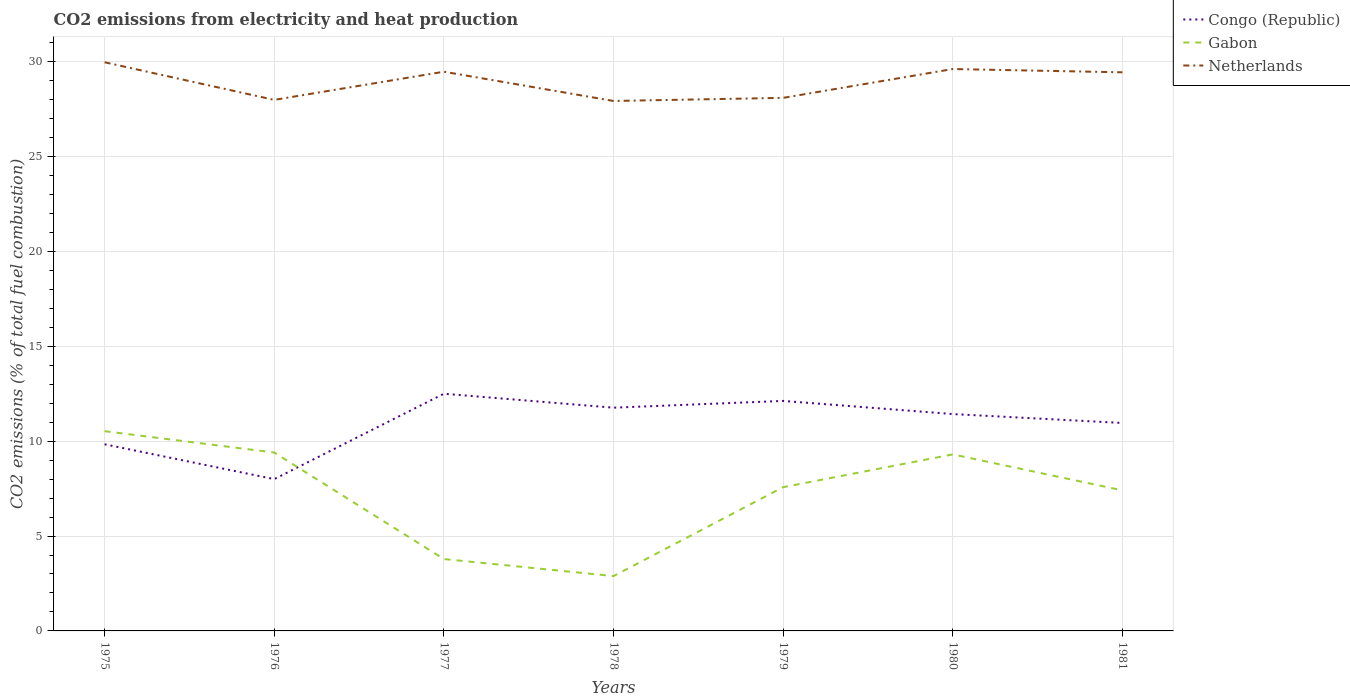Does the line corresponding to Gabon intersect with the line corresponding to Netherlands?
Your answer should be compact. No. Across all years, what is the maximum amount of CO2 emitted in Gabon?
Provide a succinct answer. 2.89. In which year was the amount of CO2 emitted in Gabon maximum?
Give a very brief answer. 1978. What is the total amount of CO2 emitted in Congo (Republic) in the graph?
Offer a very short reply. 0.47. What is the difference between the highest and the lowest amount of CO2 emitted in Gabon?
Your answer should be very brief. 5. How many lines are there?
Offer a very short reply. 3. Does the graph contain grids?
Make the answer very short. Yes. Where does the legend appear in the graph?
Make the answer very short. Top right. How are the legend labels stacked?
Make the answer very short. Vertical. What is the title of the graph?
Ensure brevity in your answer.  CO2 emissions from electricity and heat production. What is the label or title of the X-axis?
Give a very brief answer. Years. What is the label or title of the Y-axis?
Make the answer very short. CO2 emissions (% of total fuel combustion). What is the CO2 emissions (% of total fuel combustion) of Congo (Republic) in 1975?
Provide a succinct answer. 9.84. What is the CO2 emissions (% of total fuel combustion) in Gabon in 1975?
Offer a very short reply. 10.53. What is the CO2 emissions (% of total fuel combustion) in Netherlands in 1975?
Offer a terse response. 29.97. What is the CO2 emissions (% of total fuel combustion) of Gabon in 1976?
Offer a terse response. 9.4. What is the CO2 emissions (% of total fuel combustion) in Netherlands in 1976?
Provide a short and direct response. 27.99. What is the CO2 emissions (% of total fuel combustion) in Congo (Republic) in 1977?
Your response must be concise. 12.5. What is the CO2 emissions (% of total fuel combustion) of Gabon in 1977?
Keep it short and to the point. 3.79. What is the CO2 emissions (% of total fuel combustion) in Netherlands in 1977?
Your response must be concise. 29.47. What is the CO2 emissions (% of total fuel combustion) in Congo (Republic) in 1978?
Make the answer very short. 11.76. What is the CO2 emissions (% of total fuel combustion) in Gabon in 1978?
Ensure brevity in your answer.  2.89. What is the CO2 emissions (% of total fuel combustion) of Netherlands in 1978?
Your answer should be compact. 27.93. What is the CO2 emissions (% of total fuel combustion) in Congo (Republic) in 1979?
Make the answer very short. 12.12. What is the CO2 emissions (% of total fuel combustion) of Gabon in 1979?
Give a very brief answer. 7.58. What is the CO2 emissions (% of total fuel combustion) in Netherlands in 1979?
Your response must be concise. 28.09. What is the CO2 emissions (% of total fuel combustion) of Congo (Republic) in 1980?
Provide a succinct answer. 11.43. What is the CO2 emissions (% of total fuel combustion) of Gabon in 1980?
Offer a very short reply. 9.3. What is the CO2 emissions (% of total fuel combustion) of Netherlands in 1980?
Your answer should be compact. 29.61. What is the CO2 emissions (% of total fuel combustion) of Congo (Republic) in 1981?
Offer a very short reply. 10.96. What is the CO2 emissions (% of total fuel combustion) in Gabon in 1981?
Provide a short and direct response. 7.41. What is the CO2 emissions (% of total fuel combustion) of Netherlands in 1981?
Offer a very short reply. 29.44. Across all years, what is the maximum CO2 emissions (% of total fuel combustion) of Gabon?
Give a very brief answer. 10.53. Across all years, what is the maximum CO2 emissions (% of total fuel combustion) of Netherlands?
Keep it short and to the point. 29.97. Across all years, what is the minimum CO2 emissions (% of total fuel combustion) in Congo (Republic)?
Your answer should be very brief. 8. Across all years, what is the minimum CO2 emissions (% of total fuel combustion) of Gabon?
Offer a very short reply. 2.89. Across all years, what is the minimum CO2 emissions (% of total fuel combustion) of Netherlands?
Provide a short and direct response. 27.93. What is the total CO2 emissions (% of total fuel combustion) in Congo (Republic) in the graph?
Provide a succinct answer. 76.61. What is the total CO2 emissions (% of total fuel combustion) of Gabon in the graph?
Ensure brevity in your answer.  50.89. What is the total CO2 emissions (% of total fuel combustion) in Netherlands in the graph?
Your answer should be very brief. 202.5. What is the difference between the CO2 emissions (% of total fuel combustion) in Congo (Republic) in 1975 and that in 1976?
Your answer should be compact. 1.84. What is the difference between the CO2 emissions (% of total fuel combustion) of Gabon in 1975 and that in 1976?
Keep it short and to the point. 1.12. What is the difference between the CO2 emissions (% of total fuel combustion) in Netherlands in 1975 and that in 1976?
Offer a very short reply. 1.98. What is the difference between the CO2 emissions (% of total fuel combustion) of Congo (Republic) in 1975 and that in 1977?
Your answer should be compact. -2.66. What is the difference between the CO2 emissions (% of total fuel combustion) in Gabon in 1975 and that in 1977?
Make the answer very short. 6.74. What is the difference between the CO2 emissions (% of total fuel combustion) of Netherlands in 1975 and that in 1977?
Provide a short and direct response. 0.5. What is the difference between the CO2 emissions (% of total fuel combustion) in Congo (Republic) in 1975 and that in 1978?
Ensure brevity in your answer.  -1.93. What is the difference between the CO2 emissions (% of total fuel combustion) of Gabon in 1975 and that in 1978?
Make the answer very short. 7.64. What is the difference between the CO2 emissions (% of total fuel combustion) in Netherlands in 1975 and that in 1978?
Make the answer very short. 2.04. What is the difference between the CO2 emissions (% of total fuel combustion) in Congo (Republic) in 1975 and that in 1979?
Offer a terse response. -2.29. What is the difference between the CO2 emissions (% of total fuel combustion) in Gabon in 1975 and that in 1979?
Give a very brief answer. 2.95. What is the difference between the CO2 emissions (% of total fuel combustion) of Netherlands in 1975 and that in 1979?
Your answer should be compact. 1.88. What is the difference between the CO2 emissions (% of total fuel combustion) of Congo (Republic) in 1975 and that in 1980?
Offer a terse response. -1.59. What is the difference between the CO2 emissions (% of total fuel combustion) in Gabon in 1975 and that in 1980?
Ensure brevity in your answer.  1.22. What is the difference between the CO2 emissions (% of total fuel combustion) of Netherlands in 1975 and that in 1980?
Offer a very short reply. 0.36. What is the difference between the CO2 emissions (% of total fuel combustion) in Congo (Republic) in 1975 and that in 1981?
Make the answer very short. -1.12. What is the difference between the CO2 emissions (% of total fuel combustion) in Gabon in 1975 and that in 1981?
Your answer should be very brief. 3.12. What is the difference between the CO2 emissions (% of total fuel combustion) in Netherlands in 1975 and that in 1981?
Give a very brief answer. 0.53. What is the difference between the CO2 emissions (% of total fuel combustion) in Congo (Republic) in 1976 and that in 1977?
Provide a short and direct response. -4.5. What is the difference between the CO2 emissions (% of total fuel combustion) in Gabon in 1976 and that in 1977?
Offer a terse response. 5.61. What is the difference between the CO2 emissions (% of total fuel combustion) of Netherlands in 1976 and that in 1977?
Offer a very short reply. -1.48. What is the difference between the CO2 emissions (% of total fuel combustion) of Congo (Republic) in 1976 and that in 1978?
Keep it short and to the point. -3.76. What is the difference between the CO2 emissions (% of total fuel combustion) in Gabon in 1976 and that in 1978?
Your response must be concise. 6.51. What is the difference between the CO2 emissions (% of total fuel combustion) of Netherlands in 1976 and that in 1978?
Make the answer very short. 0.06. What is the difference between the CO2 emissions (% of total fuel combustion) of Congo (Republic) in 1976 and that in 1979?
Provide a short and direct response. -4.12. What is the difference between the CO2 emissions (% of total fuel combustion) of Gabon in 1976 and that in 1979?
Keep it short and to the point. 1.83. What is the difference between the CO2 emissions (% of total fuel combustion) of Netherlands in 1976 and that in 1979?
Your answer should be very brief. -0.11. What is the difference between the CO2 emissions (% of total fuel combustion) of Congo (Republic) in 1976 and that in 1980?
Offer a very short reply. -3.43. What is the difference between the CO2 emissions (% of total fuel combustion) of Gabon in 1976 and that in 1980?
Your answer should be very brief. 0.1. What is the difference between the CO2 emissions (% of total fuel combustion) in Netherlands in 1976 and that in 1980?
Your answer should be very brief. -1.63. What is the difference between the CO2 emissions (% of total fuel combustion) in Congo (Republic) in 1976 and that in 1981?
Give a very brief answer. -2.96. What is the difference between the CO2 emissions (% of total fuel combustion) of Gabon in 1976 and that in 1981?
Offer a very short reply. 1.99. What is the difference between the CO2 emissions (% of total fuel combustion) in Netherlands in 1976 and that in 1981?
Provide a short and direct response. -1.45. What is the difference between the CO2 emissions (% of total fuel combustion) of Congo (Republic) in 1977 and that in 1978?
Your answer should be compact. 0.74. What is the difference between the CO2 emissions (% of total fuel combustion) of Gabon in 1977 and that in 1978?
Offer a very short reply. 0.9. What is the difference between the CO2 emissions (% of total fuel combustion) of Netherlands in 1977 and that in 1978?
Your answer should be compact. 1.54. What is the difference between the CO2 emissions (% of total fuel combustion) of Congo (Republic) in 1977 and that in 1979?
Keep it short and to the point. 0.38. What is the difference between the CO2 emissions (% of total fuel combustion) of Gabon in 1977 and that in 1979?
Provide a short and direct response. -3.79. What is the difference between the CO2 emissions (% of total fuel combustion) of Netherlands in 1977 and that in 1979?
Your answer should be compact. 1.38. What is the difference between the CO2 emissions (% of total fuel combustion) of Congo (Republic) in 1977 and that in 1980?
Your answer should be compact. 1.07. What is the difference between the CO2 emissions (% of total fuel combustion) of Gabon in 1977 and that in 1980?
Your answer should be very brief. -5.51. What is the difference between the CO2 emissions (% of total fuel combustion) of Netherlands in 1977 and that in 1980?
Ensure brevity in your answer.  -0.14. What is the difference between the CO2 emissions (% of total fuel combustion) of Congo (Republic) in 1977 and that in 1981?
Offer a very short reply. 1.54. What is the difference between the CO2 emissions (% of total fuel combustion) in Gabon in 1977 and that in 1981?
Provide a succinct answer. -3.62. What is the difference between the CO2 emissions (% of total fuel combustion) of Netherlands in 1977 and that in 1981?
Offer a terse response. 0.03. What is the difference between the CO2 emissions (% of total fuel combustion) of Congo (Republic) in 1978 and that in 1979?
Offer a terse response. -0.36. What is the difference between the CO2 emissions (% of total fuel combustion) of Gabon in 1978 and that in 1979?
Your answer should be very brief. -4.69. What is the difference between the CO2 emissions (% of total fuel combustion) of Netherlands in 1978 and that in 1979?
Keep it short and to the point. -0.16. What is the difference between the CO2 emissions (% of total fuel combustion) of Congo (Republic) in 1978 and that in 1980?
Offer a very short reply. 0.34. What is the difference between the CO2 emissions (% of total fuel combustion) of Gabon in 1978 and that in 1980?
Keep it short and to the point. -6.41. What is the difference between the CO2 emissions (% of total fuel combustion) in Netherlands in 1978 and that in 1980?
Your answer should be compact. -1.68. What is the difference between the CO2 emissions (% of total fuel combustion) of Congo (Republic) in 1978 and that in 1981?
Your response must be concise. 0.81. What is the difference between the CO2 emissions (% of total fuel combustion) of Gabon in 1978 and that in 1981?
Your response must be concise. -4.52. What is the difference between the CO2 emissions (% of total fuel combustion) in Netherlands in 1978 and that in 1981?
Provide a succinct answer. -1.51. What is the difference between the CO2 emissions (% of total fuel combustion) of Congo (Republic) in 1979 and that in 1980?
Make the answer very short. 0.69. What is the difference between the CO2 emissions (% of total fuel combustion) of Gabon in 1979 and that in 1980?
Keep it short and to the point. -1.73. What is the difference between the CO2 emissions (% of total fuel combustion) in Netherlands in 1979 and that in 1980?
Your response must be concise. -1.52. What is the difference between the CO2 emissions (% of total fuel combustion) of Congo (Republic) in 1979 and that in 1981?
Ensure brevity in your answer.  1.16. What is the difference between the CO2 emissions (% of total fuel combustion) of Gabon in 1979 and that in 1981?
Make the answer very short. 0.17. What is the difference between the CO2 emissions (% of total fuel combustion) of Netherlands in 1979 and that in 1981?
Your answer should be very brief. -1.35. What is the difference between the CO2 emissions (% of total fuel combustion) in Congo (Republic) in 1980 and that in 1981?
Your answer should be very brief. 0.47. What is the difference between the CO2 emissions (% of total fuel combustion) of Gabon in 1980 and that in 1981?
Keep it short and to the point. 1.89. What is the difference between the CO2 emissions (% of total fuel combustion) of Netherlands in 1980 and that in 1981?
Ensure brevity in your answer.  0.17. What is the difference between the CO2 emissions (% of total fuel combustion) of Congo (Republic) in 1975 and the CO2 emissions (% of total fuel combustion) of Gabon in 1976?
Offer a very short reply. 0.43. What is the difference between the CO2 emissions (% of total fuel combustion) in Congo (Republic) in 1975 and the CO2 emissions (% of total fuel combustion) in Netherlands in 1976?
Provide a succinct answer. -18.15. What is the difference between the CO2 emissions (% of total fuel combustion) in Gabon in 1975 and the CO2 emissions (% of total fuel combustion) in Netherlands in 1976?
Your response must be concise. -17.46. What is the difference between the CO2 emissions (% of total fuel combustion) of Congo (Republic) in 1975 and the CO2 emissions (% of total fuel combustion) of Gabon in 1977?
Provide a short and direct response. 6.05. What is the difference between the CO2 emissions (% of total fuel combustion) in Congo (Republic) in 1975 and the CO2 emissions (% of total fuel combustion) in Netherlands in 1977?
Provide a short and direct response. -19.63. What is the difference between the CO2 emissions (% of total fuel combustion) in Gabon in 1975 and the CO2 emissions (% of total fuel combustion) in Netherlands in 1977?
Give a very brief answer. -18.94. What is the difference between the CO2 emissions (% of total fuel combustion) in Congo (Republic) in 1975 and the CO2 emissions (% of total fuel combustion) in Gabon in 1978?
Offer a very short reply. 6.95. What is the difference between the CO2 emissions (% of total fuel combustion) of Congo (Republic) in 1975 and the CO2 emissions (% of total fuel combustion) of Netherlands in 1978?
Offer a terse response. -18.09. What is the difference between the CO2 emissions (% of total fuel combustion) in Gabon in 1975 and the CO2 emissions (% of total fuel combustion) in Netherlands in 1978?
Give a very brief answer. -17.4. What is the difference between the CO2 emissions (% of total fuel combustion) in Congo (Republic) in 1975 and the CO2 emissions (% of total fuel combustion) in Gabon in 1979?
Offer a terse response. 2.26. What is the difference between the CO2 emissions (% of total fuel combustion) of Congo (Republic) in 1975 and the CO2 emissions (% of total fuel combustion) of Netherlands in 1979?
Your answer should be compact. -18.26. What is the difference between the CO2 emissions (% of total fuel combustion) of Gabon in 1975 and the CO2 emissions (% of total fuel combustion) of Netherlands in 1979?
Your answer should be very brief. -17.57. What is the difference between the CO2 emissions (% of total fuel combustion) in Congo (Republic) in 1975 and the CO2 emissions (% of total fuel combustion) in Gabon in 1980?
Offer a very short reply. 0.53. What is the difference between the CO2 emissions (% of total fuel combustion) of Congo (Republic) in 1975 and the CO2 emissions (% of total fuel combustion) of Netherlands in 1980?
Offer a terse response. -19.78. What is the difference between the CO2 emissions (% of total fuel combustion) in Gabon in 1975 and the CO2 emissions (% of total fuel combustion) in Netherlands in 1980?
Ensure brevity in your answer.  -19.09. What is the difference between the CO2 emissions (% of total fuel combustion) in Congo (Republic) in 1975 and the CO2 emissions (% of total fuel combustion) in Gabon in 1981?
Offer a terse response. 2.43. What is the difference between the CO2 emissions (% of total fuel combustion) in Congo (Republic) in 1975 and the CO2 emissions (% of total fuel combustion) in Netherlands in 1981?
Make the answer very short. -19.6. What is the difference between the CO2 emissions (% of total fuel combustion) in Gabon in 1975 and the CO2 emissions (% of total fuel combustion) in Netherlands in 1981?
Give a very brief answer. -18.91. What is the difference between the CO2 emissions (% of total fuel combustion) in Congo (Republic) in 1976 and the CO2 emissions (% of total fuel combustion) in Gabon in 1977?
Keep it short and to the point. 4.21. What is the difference between the CO2 emissions (% of total fuel combustion) of Congo (Republic) in 1976 and the CO2 emissions (% of total fuel combustion) of Netherlands in 1977?
Your answer should be compact. -21.47. What is the difference between the CO2 emissions (% of total fuel combustion) in Gabon in 1976 and the CO2 emissions (% of total fuel combustion) in Netherlands in 1977?
Ensure brevity in your answer.  -20.07. What is the difference between the CO2 emissions (% of total fuel combustion) of Congo (Republic) in 1976 and the CO2 emissions (% of total fuel combustion) of Gabon in 1978?
Provide a short and direct response. 5.11. What is the difference between the CO2 emissions (% of total fuel combustion) in Congo (Republic) in 1976 and the CO2 emissions (% of total fuel combustion) in Netherlands in 1978?
Provide a succinct answer. -19.93. What is the difference between the CO2 emissions (% of total fuel combustion) in Gabon in 1976 and the CO2 emissions (% of total fuel combustion) in Netherlands in 1978?
Your response must be concise. -18.53. What is the difference between the CO2 emissions (% of total fuel combustion) of Congo (Republic) in 1976 and the CO2 emissions (% of total fuel combustion) of Gabon in 1979?
Your answer should be very brief. 0.42. What is the difference between the CO2 emissions (% of total fuel combustion) in Congo (Republic) in 1976 and the CO2 emissions (% of total fuel combustion) in Netherlands in 1979?
Your answer should be compact. -20.09. What is the difference between the CO2 emissions (% of total fuel combustion) in Gabon in 1976 and the CO2 emissions (% of total fuel combustion) in Netherlands in 1979?
Make the answer very short. -18.69. What is the difference between the CO2 emissions (% of total fuel combustion) in Congo (Republic) in 1976 and the CO2 emissions (% of total fuel combustion) in Gabon in 1980?
Make the answer very short. -1.3. What is the difference between the CO2 emissions (% of total fuel combustion) in Congo (Republic) in 1976 and the CO2 emissions (% of total fuel combustion) in Netherlands in 1980?
Offer a very short reply. -21.61. What is the difference between the CO2 emissions (% of total fuel combustion) in Gabon in 1976 and the CO2 emissions (% of total fuel combustion) in Netherlands in 1980?
Provide a short and direct response. -20.21. What is the difference between the CO2 emissions (% of total fuel combustion) in Congo (Republic) in 1976 and the CO2 emissions (% of total fuel combustion) in Gabon in 1981?
Make the answer very short. 0.59. What is the difference between the CO2 emissions (% of total fuel combustion) in Congo (Republic) in 1976 and the CO2 emissions (% of total fuel combustion) in Netherlands in 1981?
Your answer should be compact. -21.44. What is the difference between the CO2 emissions (% of total fuel combustion) in Gabon in 1976 and the CO2 emissions (% of total fuel combustion) in Netherlands in 1981?
Give a very brief answer. -20.04. What is the difference between the CO2 emissions (% of total fuel combustion) in Congo (Republic) in 1977 and the CO2 emissions (% of total fuel combustion) in Gabon in 1978?
Give a very brief answer. 9.61. What is the difference between the CO2 emissions (% of total fuel combustion) of Congo (Republic) in 1977 and the CO2 emissions (% of total fuel combustion) of Netherlands in 1978?
Your answer should be compact. -15.43. What is the difference between the CO2 emissions (% of total fuel combustion) of Gabon in 1977 and the CO2 emissions (% of total fuel combustion) of Netherlands in 1978?
Your response must be concise. -24.14. What is the difference between the CO2 emissions (% of total fuel combustion) in Congo (Republic) in 1977 and the CO2 emissions (% of total fuel combustion) in Gabon in 1979?
Offer a terse response. 4.92. What is the difference between the CO2 emissions (% of total fuel combustion) in Congo (Republic) in 1977 and the CO2 emissions (% of total fuel combustion) in Netherlands in 1979?
Your answer should be compact. -15.59. What is the difference between the CO2 emissions (% of total fuel combustion) of Gabon in 1977 and the CO2 emissions (% of total fuel combustion) of Netherlands in 1979?
Ensure brevity in your answer.  -24.31. What is the difference between the CO2 emissions (% of total fuel combustion) of Congo (Republic) in 1977 and the CO2 emissions (% of total fuel combustion) of Gabon in 1980?
Ensure brevity in your answer.  3.2. What is the difference between the CO2 emissions (% of total fuel combustion) of Congo (Republic) in 1977 and the CO2 emissions (% of total fuel combustion) of Netherlands in 1980?
Your answer should be very brief. -17.11. What is the difference between the CO2 emissions (% of total fuel combustion) in Gabon in 1977 and the CO2 emissions (% of total fuel combustion) in Netherlands in 1980?
Your response must be concise. -25.82. What is the difference between the CO2 emissions (% of total fuel combustion) of Congo (Republic) in 1977 and the CO2 emissions (% of total fuel combustion) of Gabon in 1981?
Keep it short and to the point. 5.09. What is the difference between the CO2 emissions (% of total fuel combustion) of Congo (Republic) in 1977 and the CO2 emissions (% of total fuel combustion) of Netherlands in 1981?
Your response must be concise. -16.94. What is the difference between the CO2 emissions (% of total fuel combustion) in Gabon in 1977 and the CO2 emissions (% of total fuel combustion) in Netherlands in 1981?
Give a very brief answer. -25.65. What is the difference between the CO2 emissions (% of total fuel combustion) of Congo (Republic) in 1978 and the CO2 emissions (% of total fuel combustion) of Gabon in 1979?
Your answer should be very brief. 4.19. What is the difference between the CO2 emissions (% of total fuel combustion) of Congo (Republic) in 1978 and the CO2 emissions (% of total fuel combustion) of Netherlands in 1979?
Your answer should be compact. -16.33. What is the difference between the CO2 emissions (% of total fuel combustion) of Gabon in 1978 and the CO2 emissions (% of total fuel combustion) of Netherlands in 1979?
Your answer should be compact. -25.2. What is the difference between the CO2 emissions (% of total fuel combustion) in Congo (Republic) in 1978 and the CO2 emissions (% of total fuel combustion) in Gabon in 1980?
Make the answer very short. 2.46. What is the difference between the CO2 emissions (% of total fuel combustion) in Congo (Republic) in 1978 and the CO2 emissions (% of total fuel combustion) in Netherlands in 1980?
Ensure brevity in your answer.  -17.85. What is the difference between the CO2 emissions (% of total fuel combustion) of Gabon in 1978 and the CO2 emissions (% of total fuel combustion) of Netherlands in 1980?
Your response must be concise. -26.72. What is the difference between the CO2 emissions (% of total fuel combustion) in Congo (Republic) in 1978 and the CO2 emissions (% of total fuel combustion) in Gabon in 1981?
Keep it short and to the point. 4.36. What is the difference between the CO2 emissions (% of total fuel combustion) of Congo (Republic) in 1978 and the CO2 emissions (% of total fuel combustion) of Netherlands in 1981?
Your answer should be compact. -17.67. What is the difference between the CO2 emissions (% of total fuel combustion) in Gabon in 1978 and the CO2 emissions (% of total fuel combustion) in Netherlands in 1981?
Provide a short and direct response. -26.55. What is the difference between the CO2 emissions (% of total fuel combustion) of Congo (Republic) in 1979 and the CO2 emissions (% of total fuel combustion) of Gabon in 1980?
Your response must be concise. 2.82. What is the difference between the CO2 emissions (% of total fuel combustion) in Congo (Republic) in 1979 and the CO2 emissions (% of total fuel combustion) in Netherlands in 1980?
Keep it short and to the point. -17.49. What is the difference between the CO2 emissions (% of total fuel combustion) in Gabon in 1979 and the CO2 emissions (% of total fuel combustion) in Netherlands in 1980?
Your response must be concise. -22.04. What is the difference between the CO2 emissions (% of total fuel combustion) in Congo (Republic) in 1979 and the CO2 emissions (% of total fuel combustion) in Gabon in 1981?
Your answer should be compact. 4.71. What is the difference between the CO2 emissions (% of total fuel combustion) of Congo (Republic) in 1979 and the CO2 emissions (% of total fuel combustion) of Netherlands in 1981?
Your answer should be very brief. -17.32. What is the difference between the CO2 emissions (% of total fuel combustion) of Gabon in 1979 and the CO2 emissions (% of total fuel combustion) of Netherlands in 1981?
Your answer should be very brief. -21.86. What is the difference between the CO2 emissions (% of total fuel combustion) of Congo (Republic) in 1980 and the CO2 emissions (% of total fuel combustion) of Gabon in 1981?
Your answer should be very brief. 4.02. What is the difference between the CO2 emissions (% of total fuel combustion) in Congo (Republic) in 1980 and the CO2 emissions (% of total fuel combustion) in Netherlands in 1981?
Keep it short and to the point. -18.01. What is the difference between the CO2 emissions (% of total fuel combustion) in Gabon in 1980 and the CO2 emissions (% of total fuel combustion) in Netherlands in 1981?
Provide a succinct answer. -20.14. What is the average CO2 emissions (% of total fuel combustion) of Congo (Republic) per year?
Ensure brevity in your answer.  10.94. What is the average CO2 emissions (% of total fuel combustion) of Gabon per year?
Your answer should be very brief. 7.27. What is the average CO2 emissions (% of total fuel combustion) in Netherlands per year?
Keep it short and to the point. 28.93. In the year 1975, what is the difference between the CO2 emissions (% of total fuel combustion) in Congo (Republic) and CO2 emissions (% of total fuel combustion) in Gabon?
Keep it short and to the point. -0.69. In the year 1975, what is the difference between the CO2 emissions (% of total fuel combustion) of Congo (Republic) and CO2 emissions (% of total fuel combustion) of Netherlands?
Your response must be concise. -20.13. In the year 1975, what is the difference between the CO2 emissions (% of total fuel combustion) of Gabon and CO2 emissions (% of total fuel combustion) of Netherlands?
Ensure brevity in your answer.  -19.44. In the year 1976, what is the difference between the CO2 emissions (% of total fuel combustion) in Congo (Republic) and CO2 emissions (% of total fuel combustion) in Gabon?
Your answer should be very brief. -1.4. In the year 1976, what is the difference between the CO2 emissions (% of total fuel combustion) in Congo (Republic) and CO2 emissions (% of total fuel combustion) in Netherlands?
Your answer should be very brief. -19.99. In the year 1976, what is the difference between the CO2 emissions (% of total fuel combustion) of Gabon and CO2 emissions (% of total fuel combustion) of Netherlands?
Your answer should be very brief. -18.58. In the year 1977, what is the difference between the CO2 emissions (% of total fuel combustion) in Congo (Republic) and CO2 emissions (% of total fuel combustion) in Gabon?
Your answer should be very brief. 8.71. In the year 1977, what is the difference between the CO2 emissions (% of total fuel combustion) in Congo (Republic) and CO2 emissions (% of total fuel combustion) in Netherlands?
Make the answer very short. -16.97. In the year 1977, what is the difference between the CO2 emissions (% of total fuel combustion) of Gabon and CO2 emissions (% of total fuel combustion) of Netherlands?
Give a very brief answer. -25.68. In the year 1978, what is the difference between the CO2 emissions (% of total fuel combustion) in Congo (Republic) and CO2 emissions (% of total fuel combustion) in Gabon?
Your answer should be compact. 8.87. In the year 1978, what is the difference between the CO2 emissions (% of total fuel combustion) in Congo (Republic) and CO2 emissions (% of total fuel combustion) in Netherlands?
Your response must be concise. -16.16. In the year 1978, what is the difference between the CO2 emissions (% of total fuel combustion) of Gabon and CO2 emissions (% of total fuel combustion) of Netherlands?
Your answer should be compact. -25.04. In the year 1979, what is the difference between the CO2 emissions (% of total fuel combustion) in Congo (Republic) and CO2 emissions (% of total fuel combustion) in Gabon?
Provide a short and direct response. 4.55. In the year 1979, what is the difference between the CO2 emissions (% of total fuel combustion) in Congo (Republic) and CO2 emissions (% of total fuel combustion) in Netherlands?
Give a very brief answer. -15.97. In the year 1979, what is the difference between the CO2 emissions (% of total fuel combustion) of Gabon and CO2 emissions (% of total fuel combustion) of Netherlands?
Keep it short and to the point. -20.52. In the year 1980, what is the difference between the CO2 emissions (% of total fuel combustion) of Congo (Republic) and CO2 emissions (% of total fuel combustion) of Gabon?
Ensure brevity in your answer.  2.13. In the year 1980, what is the difference between the CO2 emissions (% of total fuel combustion) of Congo (Republic) and CO2 emissions (% of total fuel combustion) of Netherlands?
Offer a very short reply. -18.18. In the year 1980, what is the difference between the CO2 emissions (% of total fuel combustion) in Gabon and CO2 emissions (% of total fuel combustion) in Netherlands?
Your answer should be very brief. -20.31. In the year 1981, what is the difference between the CO2 emissions (% of total fuel combustion) of Congo (Republic) and CO2 emissions (% of total fuel combustion) of Gabon?
Your answer should be very brief. 3.55. In the year 1981, what is the difference between the CO2 emissions (% of total fuel combustion) of Congo (Republic) and CO2 emissions (% of total fuel combustion) of Netherlands?
Provide a succinct answer. -18.48. In the year 1981, what is the difference between the CO2 emissions (% of total fuel combustion) of Gabon and CO2 emissions (% of total fuel combustion) of Netherlands?
Your answer should be very brief. -22.03. What is the ratio of the CO2 emissions (% of total fuel combustion) in Congo (Republic) in 1975 to that in 1976?
Ensure brevity in your answer.  1.23. What is the ratio of the CO2 emissions (% of total fuel combustion) in Gabon in 1975 to that in 1976?
Offer a terse response. 1.12. What is the ratio of the CO2 emissions (% of total fuel combustion) of Netherlands in 1975 to that in 1976?
Your response must be concise. 1.07. What is the ratio of the CO2 emissions (% of total fuel combustion) of Congo (Republic) in 1975 to that in 1977?
Your answer should be very brief. 0.79. What is the ratio of the CO2 emissions (% of total fuel combustion) in Gabon in 1975 to that in 1977?
Give a very brief answer. 2.78. What is the ratio of the CO2 emissions (% of total fuel combustion) of Netherlands in 1975 to that in 1977?
Provide a succinct answer. 1.02. What is the ratio of the CO2 emissions (% of total fuel combustion) of Congo (Republic) in 1975 to that in 1978?
Keep it short and to the point. 0.84. What is the ratio of the CO2 emissions (% of total fuel combustion) of Gabon in 1975 to that in 1978?
Give a very brief answer. 3.64. What is the ratio of the CO2 emissions (% of total fuel combustion) in Netherlands in 1975 to that in 1978?
Keep it short and to the point. 1.07. What is the ratio of the CO2 emissions (% of total fuel combustion) in Congo (Republic) in 1975 to that in 1979?
Offer a terse response. 0.81. What is the ratio of the CO2 emissions (% of total fuel combustion) of Gabon in 1975 to that in 1979?
Provide a short and direct response. 1.39. What is the ratio of the CO2 emissions (% of total fuel combustion) in Netherlands in 1975 to that in 1979?
Keep it short and to the point. 1.07. What is the ratio of the CO2 emissions (% of total fuel combustion) of Congo (Republic) in 1975 to that in 1980?
Keep it short and to the point. 0.86. What is the ratio of the CO2 emissions (% of total fuel combustion) of Gabon in 1975 to that in 1980?
Your answer should be compact. 1.13. What is the ratio of the CO2 emissions (% of total fuel combustion) in Netherlands in 1975 to that in 1980?
Provide a short and direct response. 1.01. What is the ratio of the CO2 emissions (% of total fuel combustion) of Congo (Republic) in 1975 to that in 1981?
Provide a short and direct response. 0.9. What is the ratio of the CO2 emissions (% of total fuel combustion) of Gabon in 1975 to that in 1981?
Make the answer very short. 1.42. What is the ratio of the CO2 emissions (% of total fuel combustion) in Netherlands in 1975 to that in 1981?
Provide a short and direct response. 1.02. What is the ratio of the CO2 emissions (% of total fuel combustion) of Congo (Republic) in 1976 to that in 1977?
Ensure brevity in your answer.  0.64. What is the ratio of the CO2 emissions (% of total fuel combustion) in Gabon in 1976 to that in 1977?
Your response must be concise. 2.48. What is the ratio of the CO2 emissions (% of total fuel combustion) in Netherlands in 1976 to that in 1977?
Keep it short and to the point. 0.95. What is the ratio of the CO2 emissions (% of total fuel combustion) of Congo (Republic) in 1976 to that in 1978?
Offer a terse response. 0.68. What is the ratio of the CO2 emissions (% of total fuel combustion) of Gabon in 1976 to that in 1978?
Make the answer very short. 3.25. What is the ratio of the CO2 emissions (% of total fuel combustion) of Netherlands in 1976 to that in 1978?
Offer a terse response. 1. What is the ratio of the CO2 emissions (% of total fuel combustion) of Congo (Republic) in 1976 to that in 1979?
Offer a terse response. 0.66. What is the ratio of the CO2 emissions (% of total fuel combustion) in Gabon in 1976 to that in 1979?
Provide a succinct answer. 1.24. What is the ratio of the CO2 emissions (% of total fuel combustion) in Netherlands in 1976 to that in 1979?
Make the answer very short. 1. What is the ratio of the CO2 emissions (% of total fuel combustion) of Congo (Republic) in 1976 to that in 1980?
Your response must be concise. 0.7. What is the ratio of the CO2 emissions (% of total fuel combustion) in Gabon in 1976 to that in 1980?
Your answer should be very brief. 1.01. What is the ratio of the CO2 emissions (% of total fuel combustion) of Netherlands in 1976 to that in 1980?
Give a very brief answer. 0.95. What is the ratio of the CO2 emissions (% of total fuel combustion) in Congo (Republic) in 1976 to that in 1981?
Ensure brevity in your answer.  0.73. What is the ratio of the CO2 emissions (% of total fuel combustion) in Gabon in 1976 to that in 1981?
Your response must be concise. 1.27. What is the ratio of the CO2 emissions (% of total fuel combustion) of Netherlands in 1976 to that in 1981?
Make the answer very short. 0.95. What is the ratio of the CO2 emissions (% of total fuel combustion) of Congo (Republic) in 1977 to that in 1978?
Keep it short and to the point. 1.06. What is the ratio of the CO2 emissions (% of total fuel combustion) of Gabon in 1977 to that in 1978?
Ensure brevity in your answer.  1.31. What is the ratio of the CO2 emissions (% of total fuel combustion) in Netherlands in 1977 to that in 1978?
Offer a very short reply. 1.06. What is the ratio of the CO2 emissions (% of total fuel combustion) of Congo (Republic) in 1977 to that in 1979?
Offer a very short reply. 1.03. What is the ratio of the CO2 emissions (% of total fuel combustion) of Netherlands in 1977 to that in 1979?
Your response must be concise. 1.05. What is the ratio of the CO2 emissions (% of total fuel combustion) of Congo (Republic) in 1977 to that in 1980?
Your answer should be compact. 1.09. What is the ratio of the CO2 emissions (% of total fuel combustion) in Gabon in 1977 to that in 1980?
Your answer should be very brief. 0.41. What is the ratio of the CO2 emissions (% of total fuel combustion) in Congo (Republic) in 1977 to that in 1981?
Your answer should be very brief. 1.14. What is the ratio of the CO2 emissions (% of total fuel combustion) in Gabon in 1977 to that in 1981?
Offer a terse response. 0.51. What is the ratio of the CO2 emissions (% of total fuel combustion) in Congo (Republic) in 1978 to that in 1979?
Your answer should be very brief. 0.97. What is the ratio of the CO2 emissions (% of total fuel combustion) in Gabon in 1978 to that in 1979?
Your answer should be compact. 0.38. What is the ratio of the CO2 emissions (% of total fuel combustion) in Netherlands in 1978 to that in 1979?
Provide a succinct answer. 0.99. What is the ratio of the CO2 emissions (% of total fuel combustion) in Congo (Republic) in 1978 to that in 1980?
Make the answer very short. 1.03. What is the ratio of the CO2 emissions (% of total fuel combustion) of Gabon in 1978 to that in 1980?
Your response must be concise. 0.31. What is the ratio of the CO2 emissions (% of total fuel combustion) in Netherlands in 1978 to that in 1980?
Your answer should be compact. 0.94. What is the ratio of the CO2 emissions (% of total fuel combustion) of Congo (Republic) in 1978 to that in 1981?
Offer a terse response. 1.07. What is the ratio of the CO2 emissions (% of total fuel combustion) in Gabon in 1978 to that in 1981?
Offer a very short reply. 0.39. What is the ratio of the CO2 emissions (% of total fuel combustion) of Netherlands in 1978 to that in 1981?
Provide a short and direct response. 0.95. What is the ratio of the CO2 emissions (% of total fuel combustion) of Congo (Republic) in 1979 to that in 1980?
Provide a short and direct response. 1.06. What is the ratio of the CO2 emissions (% of total fuel combustion) of Gabon in 1979 to that in 1980?
Your answer should be compact. 0.81. What is the ratio of the CO2 emissions (% of total fuel combustion) of Netherlands in 1979 to that in 1980?
Give a very brief answer. 0.95. What is the ratio of the CO2 emissions (% of total fuel combustion) of Congo (Republic) in 1979 to that in 1981?
Ensure brevity in your answer.  1.11. What is the ratio of the CO2 emissions (% of total fuel combustion) of Gabon in 1979 to that in 1981?
Ensure brevity in your answer.  1.02. What is the ratio of the CO2 emissions (% of total fuel combustion) in Netherlands in 1979 to that in 1981?
Provide a short and direct response. 0.95. What is the ratio of the CO2 emissions (% of total fuel combustion) of Congo (Republic) in 1980 to that in 1981?
Your response must be concise. 1.04. What is the ratio of the CO2 emissions (% of total fuel combustion) of Gabon in 1980 to that in 1981?
Ensure brevity in your answer.  1.26. What is the ratio of the CO2 emissions (% of total fuel combustion) in Netherlands in 1980 to that in 1981?
Offer a very short reply. 1.01. What is the difference between the highest and the second highest CO2 emissions (% of total fuel combustion) in Congo (Republic)?
Give a very brief answer. 0.38. What is the difference between the highest and the second highest CO2 emissions (% of total fuel combustion) of Gabon?
Make the answer very short. 1.12. What is the difference between the highest and the second highest CO2 emissions (% of total fuel combustion) in Netherlands?
Your answer should be very brief. 0.36. What is the difference between the highest and the lowest CO2 emissions (% of total fuel combustion) of Gabon?
Your answer should be compact. 7.64. What is the difference between the highest and the lowest CO2 emissions (% of total fuel combustion) in Netherlands?
Provide a short and direct response. 2.04. 